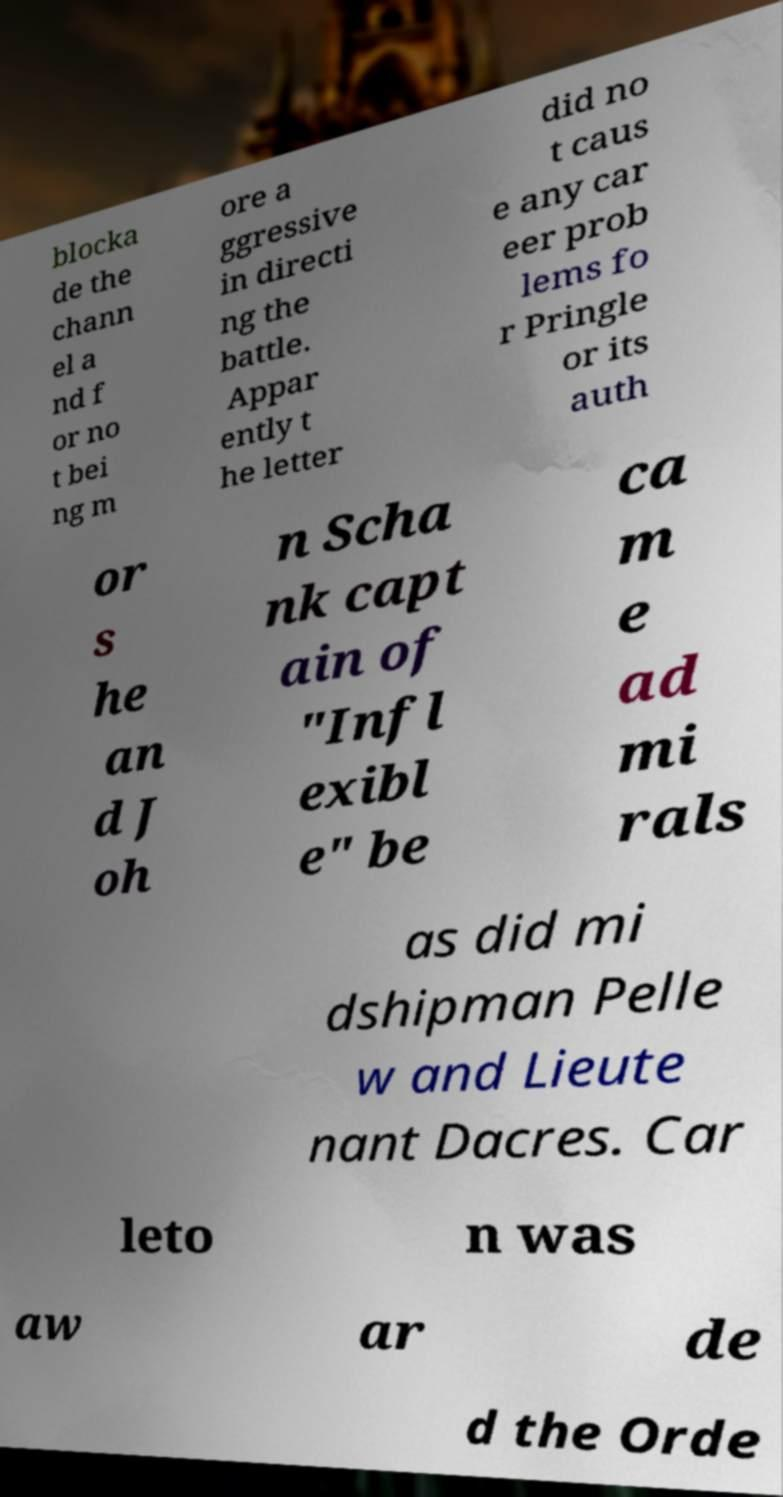What messages or text are displayed in this image? I need them in a readable, typed format. blocka de the chann el a nd f or no t bei ng m ore a ggressive in directi ng the battle. Appar ently t he letter did no t caus e any car eer prob lems fo r Pringle or its auth or s he an d J oh n Scha nk capt ain of "Infl exibl e" be ca m e ad mi rals as did mi dshipman Pelle w and Lieute nant Dacres. Car leto n was aw ar de d the Orde 